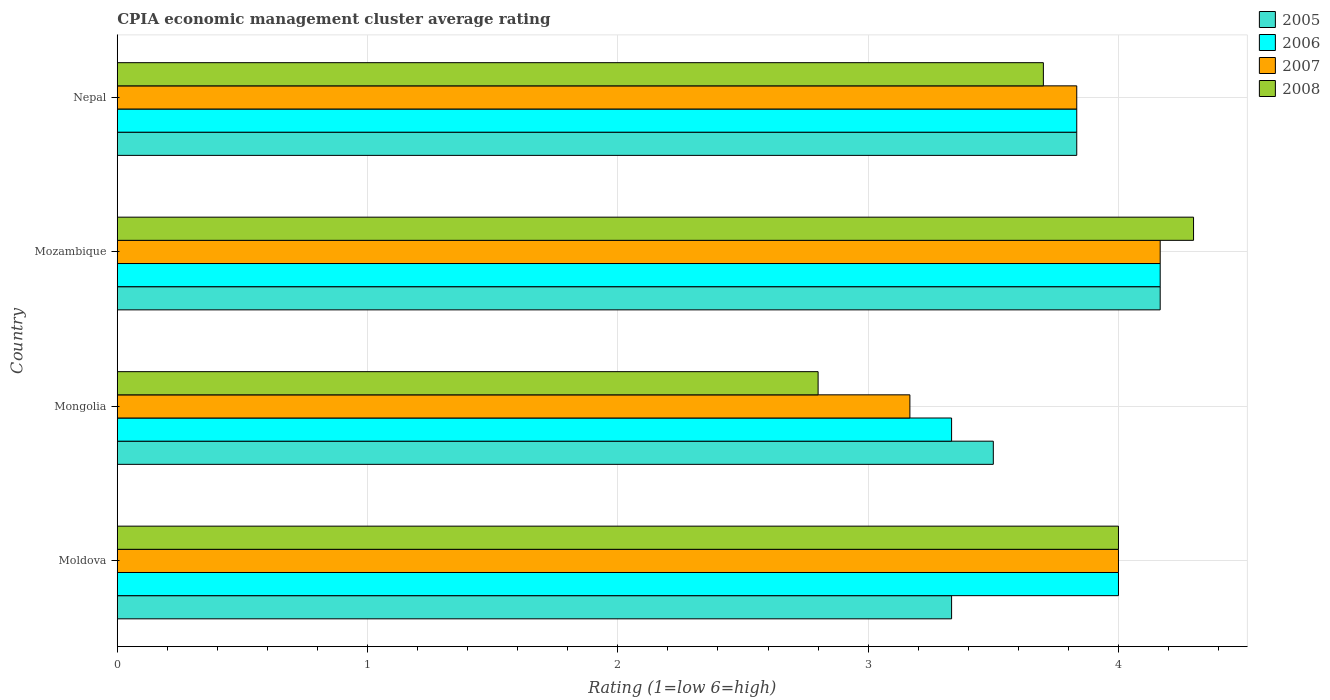How many different coloured bars are there?
Your response must be concise. 4. Are the number of bars per tick equal to the number of legend labels?
Your answer should be very brief. Yes. How many bars are there on the 2nd tick from the top?
Your answer should be very brief. 4. How many bars are there on the 1st tick from the bottom?
Provide a succinct answer. 4. What is the label of the 4th group of bars from the top?
Your response must be concise. Moldova. In how many cases, is the number of bars for a given country not equal to the number of legend labels?
Provide a succinct answer. 0. What is the CPIA rating in 2008 in Nepal?
Offer a terse response. 3.7. Across all countries, what is the maximum CPIA rating in 2006?
Offer a very short reply. 4.17. Across all countries, what is the minimum CPIA rating in 2005?
Keep it short and to the point. 3.33. In which country was the CPIA rating in 2005 maximum?
Provide a short and direct response. Mozambique. In which country was the CPIA rating in 2005 minimum?
Offer a terse response. Moldova. What is the difference between the CPIA rating in 2006 in Mongolia and that in Nepal?
Your response must be concise. -0.5. What is the difference between the CPIA rating in 2007 in Mozambique and the CPIA rating in 2005 in Nepal?
Provide a short and direct response. 0.33. What is the average CPIA rating in 2006 per country?
Provide a short and direct response. 3.83. What is the difference between the CPIA rating in 2005 and CPIA rating in 2007 in Mozambique?
Your answer should be compact. 0. In how many countries, is the CPIA rating in 2008 greater than 3 ?
Keep it short and to the point. 3. What is the ratio of the CPIA rating in 2008 in Moldova to that in Mongolia?
Your answer should be very brief. 1.43. Is the difference between the CPIA rating in 2005 in Moldova and Mongolia greater than the difference between the CPIA rating in 2007 in Moldova and Mongolia?
Offer a very short reply. No. What is the difference between the highest and the second highest CPIA rating in 2007?
Your answer should be compact. 0.17. What is the difference between the highest and the lowest CPIA rating in 2008?
Give a very brief answer. 1.5. In how many countries, is the CPIA rating in 2006 greater than the average CPIA rating in 2006 taken over all countries?
Provide a short and direct response. 2. Is it the case that in every country, the sum of the CPIA rating in 2005 and CPIA rating in 2006 is greater than the sum of CPIA rating in 2007 and CPIA rating in 2008?
Give a very brief answer. No. What does the 4th bar from the bottom in Moldova represents?
Offer a terse response. 2008. How many bars are there?
Provide a succinct answer. 16. What is the difference between two consecutive major ticks on the X-axis?
Provide a succinct answer. 1. Does the graph contain grids?
Provide a short and direct response. Yes. Where does the legend appear in the graph?
Your response must be concise. Top right. How are the legend labels stacked?
Your answer should be compact. Vertical. What is the title of the graph?
Offer a very short reply. CPIA economic management cluster average rating. Does "2000" appear as one of the legend labels in the graph?
Keep it short and to the point. No. What is the label or title of the X-axis?
Offer a terse response. Rating (1=low 6=high). What is the label or title of the Y-axis?
Your answer should be very brief. Country. What is the Rating (1=low 6=high) in 2005 in Moldova?
Provide a succinct answer. 3.33. What is the Rating (1=low 6=high) in 2006 in Moldova?
Your answer should be compact. 4. What is the Rating (1=low 6=high) of 2008 in Moldova?
Keep it short and to the point. 4. What is the Rating (1=low 6=high) of 2006 in Mongolia?
Your response must be concise. 3.33. What is the Rating (1=low 6=high) of 2007 in Mongolia?
Provide a short and direct response. 3.17. What is the Rating (1=low 6=high) in 2005 in Mozambique?
Offer a very short reply. 4.17. What is the Rating (1=low 6=high) in 2006 in Mozambique?
Your answer should be compact. 4.17. What is the Rating (1=low 6=high) of 2007 in Mozambique?
Your answer should be very brief. 4.17. What is the Rating (1=low 6=high) in 2005 in Nepal?
Ensure brevity in your answer.  3.83. What is the Rating (1=low 6=high) of 2006 in Nepal?
Ensure brevity in your answer.  3.83. What is the Rating (1=low 6=high) of 2007 in Nepal?
Provide a succinct answer. 3.83. Across all countries, what is the maximum Rating (1=low 6=high) of 2005?
Offer a terse response. 4.17. Across all countries, what is the maximum Rating (1=low 6=high) in 2006?
Provide a short and direct response. 4.17. Across all countries, what is the maximum Rating (1=low 6=high) in 2007?
Provide a short and direct response. 4.17. Across all countries, what is the maximum Rating (1=low 6=high) in 2008?
Give a very brief answer. 4.3. Across all countries, what is the minimum Rating (1=low 6=high) in 2005?
Offer a terse response. 3.33. Across all countries, what is the minimum Rating (1=low 6=high) of 2006?
Offer a terse response. 3.33. Across all countries, what is the minimum Rating (1=low 6=high) of 2007?
Provide a short and direct response. 3.17. Across all countries, what is the minimum Rating (1=low 6=high) of 2008?
Your answer should be compact. 2.8. What is the total Rating (1=low 6=high) in 2005 in the graph?
Your answer should be very brief. 14.83. What is the total Rating (1=low 6=high) of 2006 in the graph?
Your answer should be very brief. 15.33. What is the total Rating (1=low 6=high) of 2007 in the graph?
Keep it short and to the point. 15.17. What is the total Rating (1=low 6=high) of 2008 in the graph?
Offer a terse response. 14.8. What is the difference between the Rating (1=low 6=high) of 2005 in Moldova and that in Mongolia?
Your answer should be very brief. -0.17. What is the difference between the Rating (1=low 6=high) of 2006 in Moldova and that in Mongolia?
Your answer should be compact. 0.67. What is the difference between the Rating (1=low 6=high) in 2007 in Moldova and that in Mongolia?
Keep it short and to the point. 0.83. What is the difference between the Rating (1=low 6=high) in 2008 in Moldova and that in Mongolia?
Keep it short and to the point. 1.2. What is the difference between the Rating (1=low 6=high) in 2005 in Moldova and that in Mozambique?
Make the answer very short. -0.83. What is the difference between the Rating (1=low 6=high) of 2006 in Moldova and that in Mozambique?
Ensure brevity in your answer.  -0.17. What is the difference between the Rating (1=low 6=high) in 2008 in Moldova and that in Mozambique?
Your answer should be compact. -0.3. What is the difference between the Rating (1=low 6=high) in 2005 in Moldova and that in Nepal?
Offer a terse response. -0.5. What is the difference between the Rating (1=low 6=high) in 2007 in Moldova and that in Nepal?
Ensure brevity in your answer.  0.17. What is the difference between the Rating (1=low 6=high) in 2005 in Mongolia and that in Mozambique?
Provide a short and direct response. -0.67. What is the difference between the Rating (1=low 6=high) in 2006 in Mongolia and that in Mozambique?
Ensure brevity in your answer.  -0.83. What is the difference between the Rating (1=low 6=high) in 2008 in Mongolia and that in Mozambique?
Keep it short and to the point. -1.5. What is the difference between the Rating (1=low 6=high) of 2005 in Mongolia and that in Nepal?
Your answer should be very brief. -0.33. What is the difference between the Rating (1=low 6=high) of 2007 in Mongolia and that in Nepal?
Offer a terse response. -0.67. What is the difference between the Rating (1=low 6=high) of 2005 in Mozambique and that in Nepal?
Offer a terse response. 0.33. What is the difference between the Rating (1=low 6=high) of 2006 in Mozambique and that in Nepal?
Your response must be concise. 0.33. What is the difference between the Rating (1=low 6=high) of 2007 in Mozambique and that in Nepal?
Your response must be concise. 0.33. What is the difference between the Rating (1=low 6=high) of 2005 in Moldova and the Rating (1=low 6=high) of 2006 in Mongolia?
Give a very brief answer. 0. What is the difference between the Rating (1=low 6=high) of 2005 in Moldova and the Rating (1=low 6=high) of 2007 in Mongolia?
Offer a terse response. 0.17. What is the difference between the Rating (1=low 6=high) in 2005 in Moldova and the Rating (1=low 6=high) in 2008 in Mongolia?
Make the answer very short. 0.53. What is the difference between the Rating (1=low 6=high) of 2006 in Moldova and the Rating (1=low 6=high) of 2008 in Mongolia?
Ensure brevity in your answer.  1.2. What is the difference between the Rating (1=low 6=high) of 2007 in Moldova and the Rating (1=low 6=high) of 2008 in Mongolia?
Your answer should be very brief. 1.2. What is the difference between the Rating (1=low 6=high) of 2005 in Moldova and the Rating (1=low 6=high) of 2006 in Mozambique?
Your answer should be compact. -0.83. What is the difference between the Rating (1=low 6=high) of 2005 in Moldova and the Rating (1=low 6=high) of 2008 in Mozambique?
Your response must be concise. -0.97. What is the difference between the Rating (1=low 6=high) of 2005 in Moldova and the Rating (1=low 6=high) of 2006 in Nepal?
Keep it short and to the point. -0.5. What is the difference between the Rating (1=low 6=high) of 2005 in Moldova and the Rating (1=low 6=high) of 2007 in Nepal?
Your response must be concise. -0.5. What is the difference between the Rating (1=low 6=high) of 2005 in Moldova and the Rating (1=low 6=high) of 2008 in Nepal?
Provide a succinct answer. -0.37. What is the difference between the Rating (1=low 6=high) of 2006 in Moldova and the Rating (1=low 6=high) of 2007 in Nepal?
Your answer should be compact. 0.17. What is the difference between the Rating (1=low 6=high) of 2007 in Moldova and the Rating (1=low 6=high) of 2008 in Nepal?
Your response must be concise. 0.3. What is the difference between the Rating (1=low 6=high) of 2005 in Mongolia and the Rating (1=low 6=high) of 2006 in Mozambique?
Keep it short and to the point. -0.67. What is the difference between the Rating (1=low 6=high) in 2005 in Mongolia and the Rating (1=low 6=high) in 2007 in Mozambique?
Your response must be concise. -0.67. What is the difference between the Rating (1=low 6=high) in 2006 in Mongolia and the Rating (1=low 6=high) in 2007 in Mozambique?
Offer a very short reply. -0.83. What is the difference between the Rating (1=low 6=high) in 2006 in Mongolia and the Rating (1=low 6=high) in 2008 in Mozambique?
Your answer should be very brief. -0.97. What is the difference between the Rating (1=low 6=high) of 2007 in Mongolia and the Rating (1=low 6=high) of 2008 in Mozambique?
Your answer should be compact. -1.13. What is the difference between the Rating (1=low 6=high) in 2005 in Mongolia and the Rating (1=low 6=high) in 2008 in Nepal?
Your answer should be compact. -0.2. What is the difference between the Rating (1=low 6=high) of 2006 in Mongolia and the Rating (1=low 6=high) of 2008 in Nepal?
Offer a terse response. -0.37. What is the difference between the Rating (1=low 6=high) in 2007 in Mongolia and the Rating (1=low 6=high) in 2008 in Nepal?
Provide a succinct answer. -0.53. What is the difference between the Rating (1=low 6=high) of 2005 in Mozambique and the Rating (1=low 6=high) of 2006 in Nepal?
Your answer should be very brief. 0.33. What is the difference between the Rating (1=low 6=high) in 2005 in Mozambique and the Rating (1=low 6=high) in 2008 in Nepal?
Offer a terse response. 0.47. What is the difference between the Rating (1=low 6=high) of 2006 in Mozambique and the Rating (1=low 6=high) of 2007 in Nepal?
Provide a short and direct response. 0.33. What is the difference between the Rating (1=low 6=high) in 2006 in Mozambique and the Rating (1=low 6=high) in 2008 in Nepal?
Keep it short and to the point. 0.47. What is the difference between the Rating (1=low 6=high) of 2007 in Mozambique and the Rating (1=low 6=high) of 2008 in Nepal?
Offer a very short reply. 0.47. What is the average Rating (1=low 6=high) in 2005 per country?
Provide a succinct answer. 3.71. What is the average Rating (1=low 6=high) in 2006 per country?
Your answer should be compact. 3.83. What is the average Rating (1=low 6=high) of 2007 per country?
Provide a succinct answer. 3.79. What is the average Rating (1=low 6=high) in 2008 per country?
Your response must be concise. 3.7. What is the difference between the Rating (1=low 6=high) in 2005 and Rating (1=low 6=high) in 2007 in Moldova?
Give a very brief answer. -0.67. What is the difference between the Rating (1=low 6=high) of 2007 and Rating (1=low 6=high) of 2008 in Moldova?
Give a very brief answer. 0. What is the difference between the Rating (1=low 6=high) of 2005 and Rating (1=low 6=high) of 2006 in Mongolia?
Give a very brief answer. 0.17. What is the difference between the Rating (1=low 6=high) of 2005 and Rating (1=low 6=high) of 2007 in Mongolia?
Offer a very short reply. 0.33. What is the difference between the Rating (1=low 6=high) of 2006 and Rating (1=low 6=high) of 2007 in Mongolia?
Provide a succinct answer. 0.17. What is the difference between the Rating (1=low 6=high) of 2006 and Rating (1=low 6=high) of 2008 in Mongolia?
Make the answer very short. 0.53. What is the difference between the Rating (1=low 6=high) in 2007 and Rating (1=low 6=high) in 2008 in Mongolia?
Keep it short and to the point. 0.37. What is the difference between the Rating (1=low 6=high) in 2005 and Rating (1=low 6=high) in 2008 in Mozambique?
Your response must be concise. -0.13. What is the difference between the Rating (1=low 6=high) of 2006 and Rating (1=low 6=high) of 2007 in Mozambique?
Provide a short and direct response. 0. What is the difference between the Rating (1=low 6=high) in 2006 and Rating (1=low 6=high) in 2008 in Mozambique?
Offer a very short reply. -0.13. What is the difference between the Rating (1=low 6=high) in 2007 and Rating (1=low 6=high) in 2008 in Mozambique?
Your answer should be very brief. -0.13. What is the difference between the Rating (1=low 6=high) in 2005 and Rating (1=low 6=high) in 2006 in Nepal?
Your answer should be very brief. 0. What is the difference between the Rating (1=low 6=high) of 2005 and Rating (1=low 6=high) of 2008 in Nepal?
Offer a terse response. 0.13. What is the difference between the Rating (1=low 6=high) of 2006 and Rating (1=low 6=high) of 2008 in Nepal?
Ensure brevity in your answer.  0.13. What is the difference between the Rating (1=low 6=high) of 2007 and Rating (1=low 6=high) of 2008 in Nepal?
Your answer should be very brief. 0.13. What is the ratio of the Rating (1=low 6=high) in 2007 in Moldova to that in Mongolia?
Your answer should be compact. 1.26. What is the ratio of the Rating (1=low 6=high) in 2008 in Moldova to that in Mongolia?
Your response must be concise. 1.43. What is the ratio of the Rating (1=low 6=high) in 2005 in Moldova to that in Mozambique?
Your answer should be compact. 0.8. What is the ratio of the Rating (1=low 6=high) in 2006 in Moldova to that in Mozambique?
Your answer should be very brief. 0.96. What is the ratio of the Rating (1=low 6=high) in 2008 in Moldova to that in Mozambique?
Your answer should be compact. 0.93. What is the ratio of the Rating (1=low 6=high) of 2005 in Moldova to that in Nepal?
Your response must be concise. 0.87. What is the ratio of the Rating (1=low 6=high) of 2006 in Moldova to that in Nepal?
Provide a succinct answer. 1.04. What is the ratio of the Rating (1=low 6=high) in 2007 in Moldova to that in Nepal?
Make the answer very short. 1.04. What is the ratio of the Rating (1=low 6=high) of 2008 in Moldova to that in Nepal?
Ensure brevity in your answer.  1.08. What is the ratio of the Rating (1=low 6=high) in 2005 in Mongolia to that in Mozambique?
Your response must be concise. 0.84. What is the ratio of the Rating (1=low 6=high) in 2007 in Mongolia to that in Mozambique?
Keep it short and to the point. 0.76. What is the ratio of the Rating (1=low 6=high) in 2008 in Mongolia to that in Mozambique?
Offer a very short reply. 0.65. What is the ratio of the Rating (1=low 6=high) of 2005 in Mongolia to that in Nepal?
Give a very brief answer. 0.91. What is the ratio of the Rating (1=low 6=high) of 2006 in Mongolia to that in Nepal?
Make the answer very short. 0.87. What is the ratio of the Rating (1=low 6=high) in 2007 in Mongolia to that in Nepal?
Ensure brevity in your answer.  0.83. What is the ratio of the Rating (1=low 6=high) of 2008 in Mongolia to that in Nepal?
Your response must be concise. 0.76. What is the ratio of the Rating (1=low 6=high) of 2005 in Mozambique to that in Nepal?
Your answer should be very brief. 1.09. What is the ratio of the Rating (1=low 6=high) of 2006 in Mozambique to that in Nepal?
Give a very brief answer. 1.09. What is the ratio of the Rating (1=low 6=high) in 2007 in Mozambique to that in Nepal?
Your answer should be very brief. 1.09. What is the ratio of the Rating (1=low 6=high) of 2008 in Mozambique to that in Nepal?
Provide a succinct answer. 1.16. What is the difference between the highest and the second highest Rating (1=low 6=high) of 2005?
Make the answer very short. 0.33. What is the difference between the highest and the second highest Rating (1=low 6=high) in 2007?
Your answer should be compact. 0.17. What is the difference between the highest and the second highest Rating (1=low 6=high) of 2008?
Your answer should be compact. 0.3. 